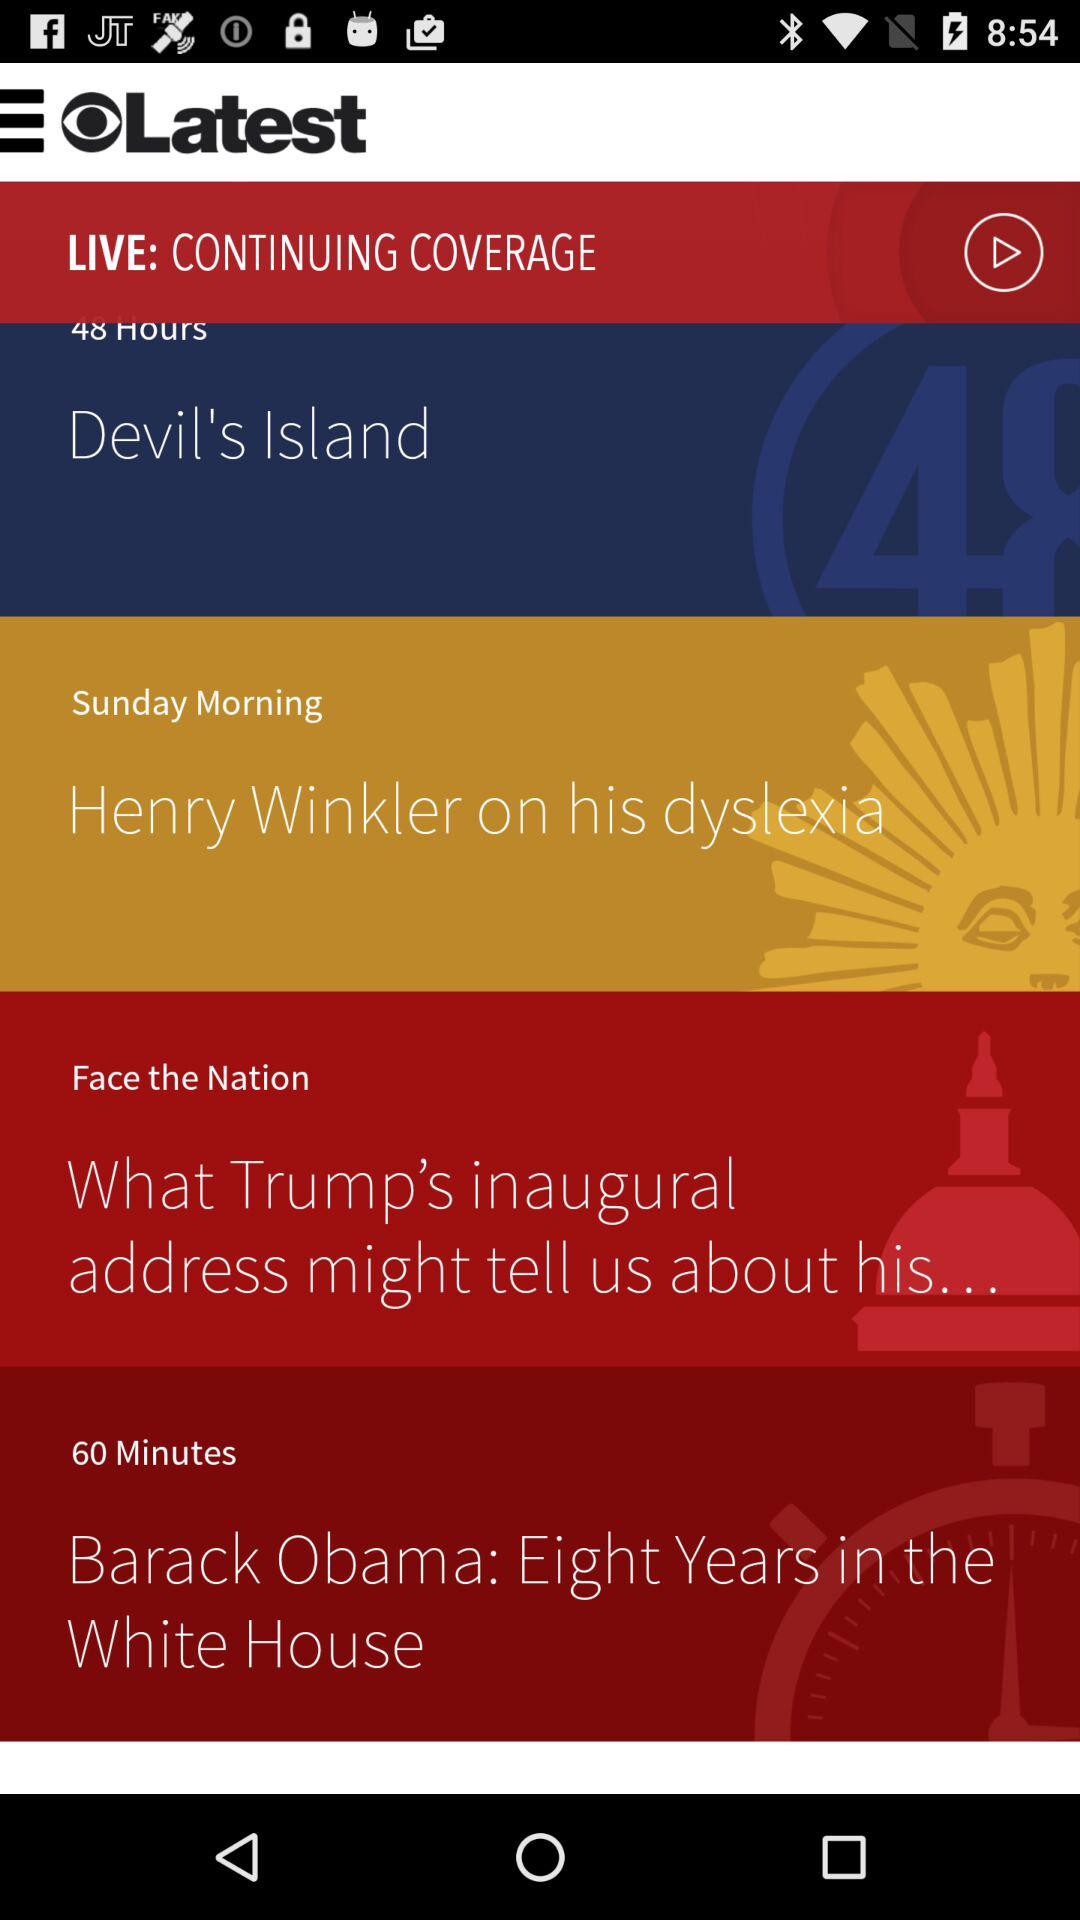When will the live coverage for "Henry Winkler on his dyslexia" be broadcast? It will be broadcast on Sunday morning. 